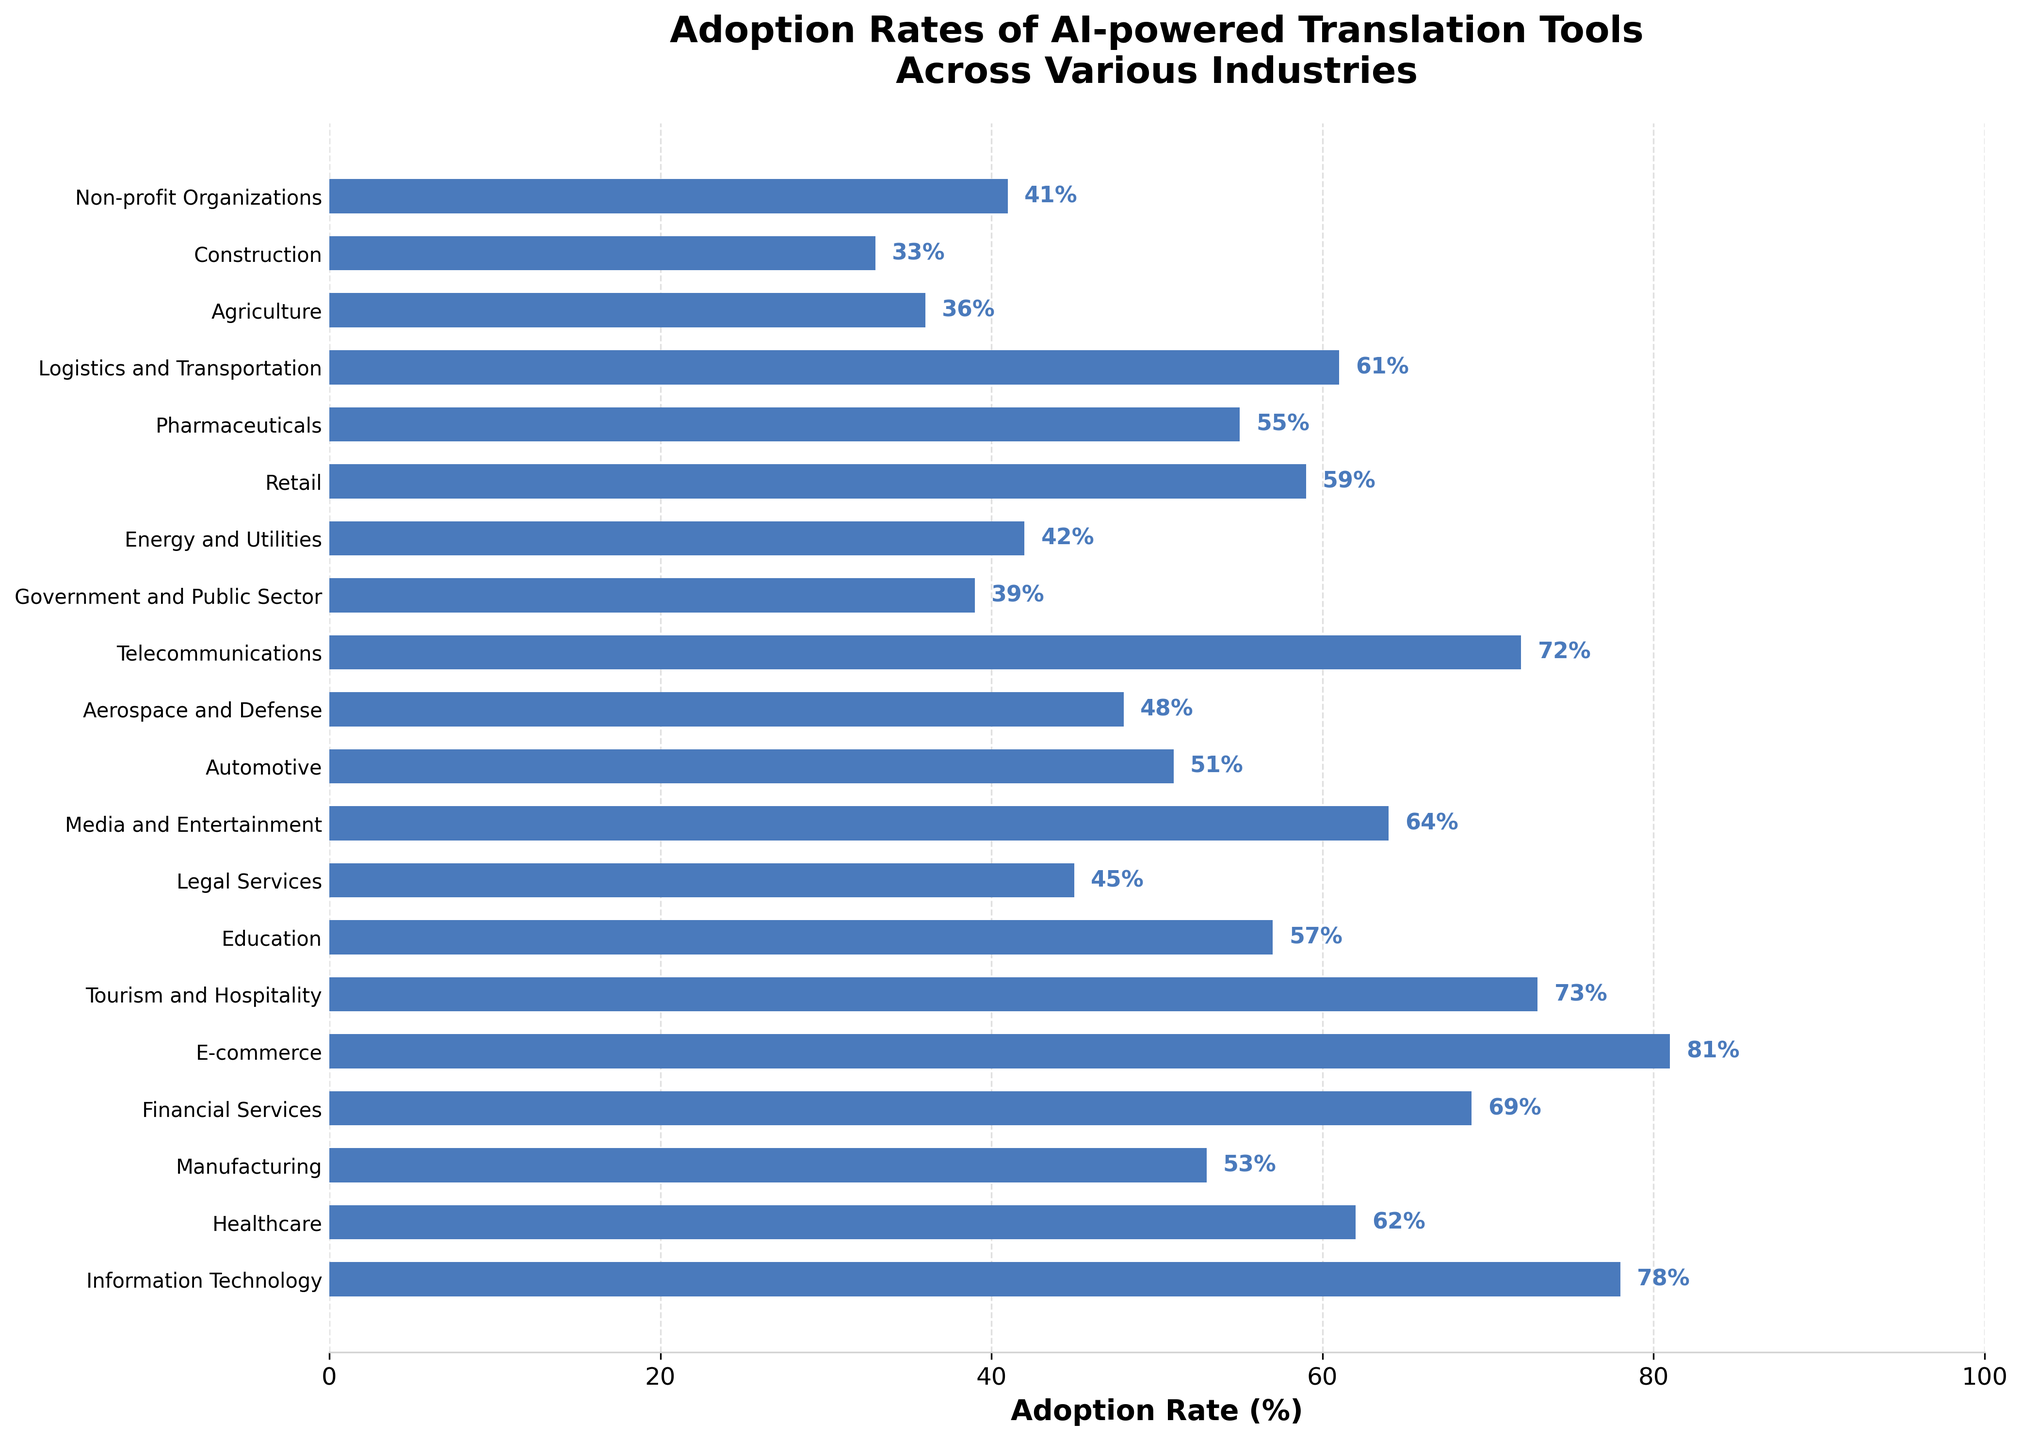Which industry has the highest adoption rate of AI-powered translation tools? The tallest bar represents the industry with the highest adoption rate. In the chart, the e-commerce industry has the highest value.
Answer: E-commerce Which industry has the lowest adoption rate of AI-powered translation tools? The shortest bar represents the industry with the lowest adoption rate. In the chart, the construction industry has the lowest value.
Answer: Construction Which industry has a higher adoption rate: Healthcare or Tourism and Hospitality? Compare the length of the bars for Healthcare (62%) and Tourism and Hospitality (73%). Since the bar for Tourism and Hospitality is longer, it has a higher adoption rate.
Answer: Tourism and Hospitality What's the difference in adoption rate between the Financial Services and the Legal Services industries? Find the values for Financial Services (69%) and Legal Services (45%). Calculate the difference: 69% - 45% = 24%.
Answer: 24% What is the average adoption rate of AI-powered translation tools across the Information Technology, E-commerce, and Telecommunications industries? Add the rates for Information Technology (78%), E-commerce (81%), and Telecommunications (72%) and divide by 3: (78 + 81 + 72) / 3 = 77.
Answer: 77% How many industries have an adoption rate of less than 50%? Identify the bars with values less than 50%: Legal Services (45%), Automotive (51%), Aerospace and Defense (48%), Government and Public Sector (39%), Energy and Utilities (42%), Agriculture (36%), Construction (33%), and Non-profit Organizations (41%). Count these industries: 7.
Answer: 7 Which industries have adoption rates between 50% and 60%? Identify bars with values between 50% and 60%: Manufacturing (53%), Education (57%), Retail (59%), Pharmaceuticals (55%), Logistics and Transportation (61%), and Automotive (51%). List these industries.
Answer: Manufacturing, Education, Retail, Pharmaceuticals, Automotive Compare the adoption rates of the Energy and Utilities and the Government and Public Sector. Which one is higher and by how much? Compare the bars for Energy and Utilities (42%) and Government and Public Sector (39%). Energy and Utilities is higher. Calculate the difference: 42% - 39% = 3%.
Answer: Energy and Utilities, 3% Which industry just missed reaching a 60% adoption rate of AI-powered translation tools? Look for the industry closest to but below 60%. The Pharmaceuticals industry has a rate of 59%, which is just below 60%.
Answer: Pharmaceuticals What is the combined adoption rate of AI-powered translation tools among the Manufacturing, Media and Entertainment, and Automotive industries? Add the adoption rates for Manufacturing (53%), Media and Entertainment (64%), and Automotive (51%): 53 + 64 + 51 = 168.
Answer: 168% 